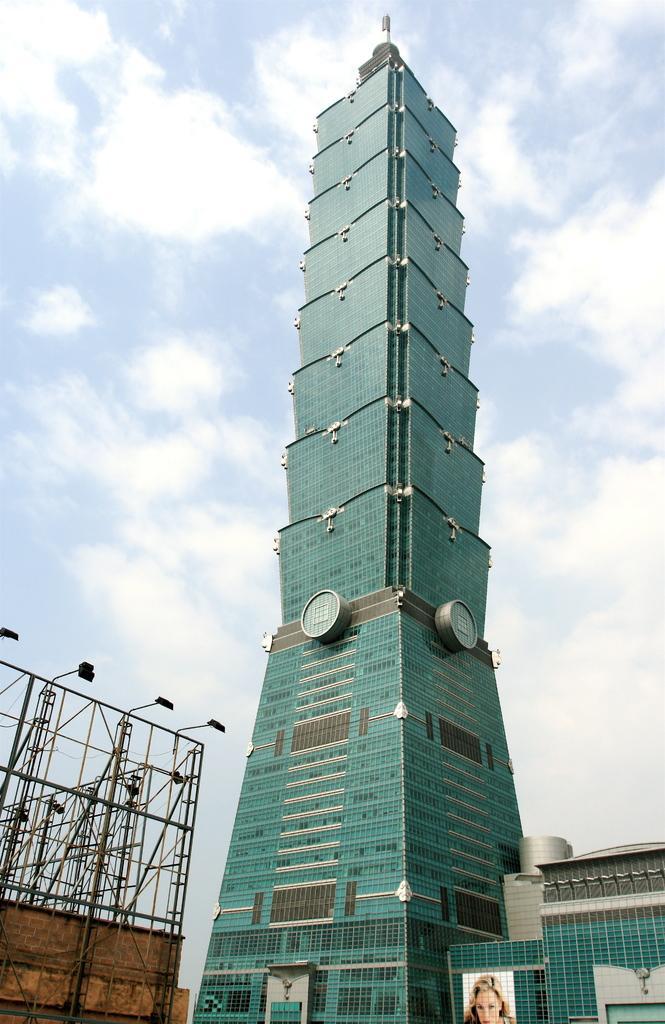In one or two sentences, can you explain what this image depicts? This image consists of a skyscraper in green color. On the left, there is a stand of a hoarding. At the top, there are clouds in the sky. 